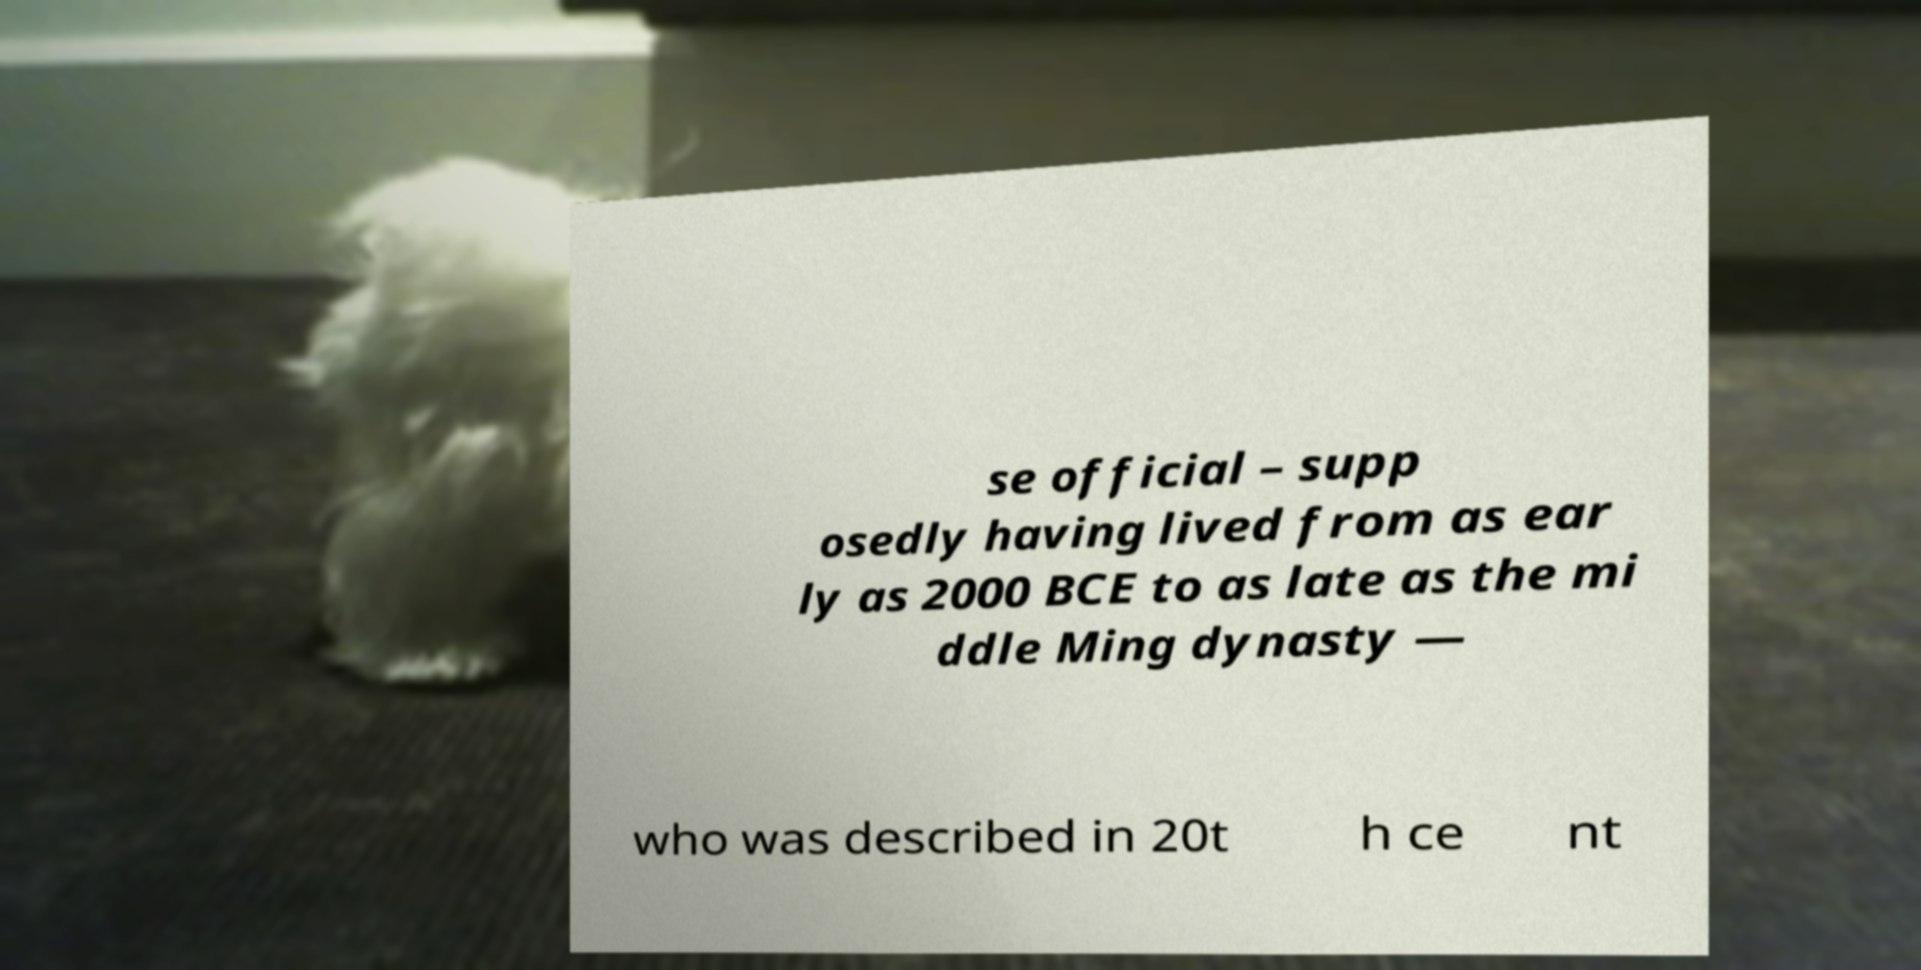Can you accurately transcribe the text from the provided image for me? se official – supp osedly having lived from as ear ly as 2000 BCE to as late as the mi ddle Ming dynasty — who was described in 20t h ce nt 